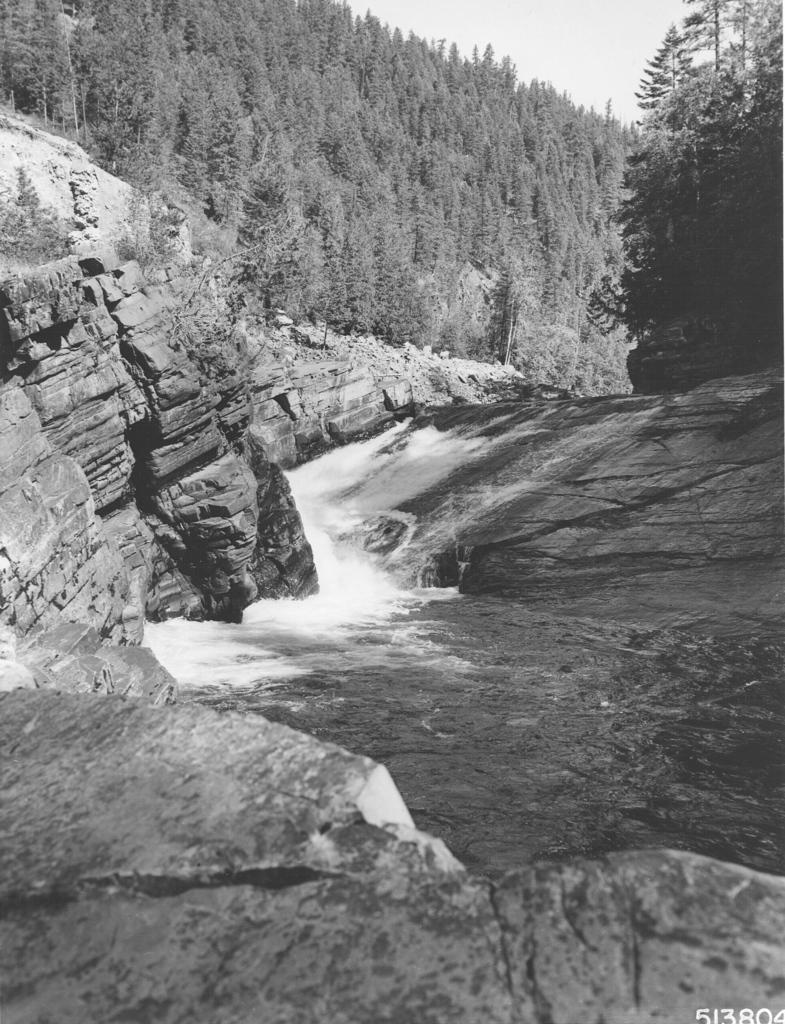What is the color scheme of the image? The image is black and white. What is located in the foreground of the image? There is a river in the foreground of the image. What can be seen on either side of the river? There are rocks on either side of the river. What is visible in the background of the image? There are trees and the sky in the background of the image. What type of knot is being used to secure the wire in the image? There is no wire or knot present in the image; it features a river, rocks, trees, and the sky. 